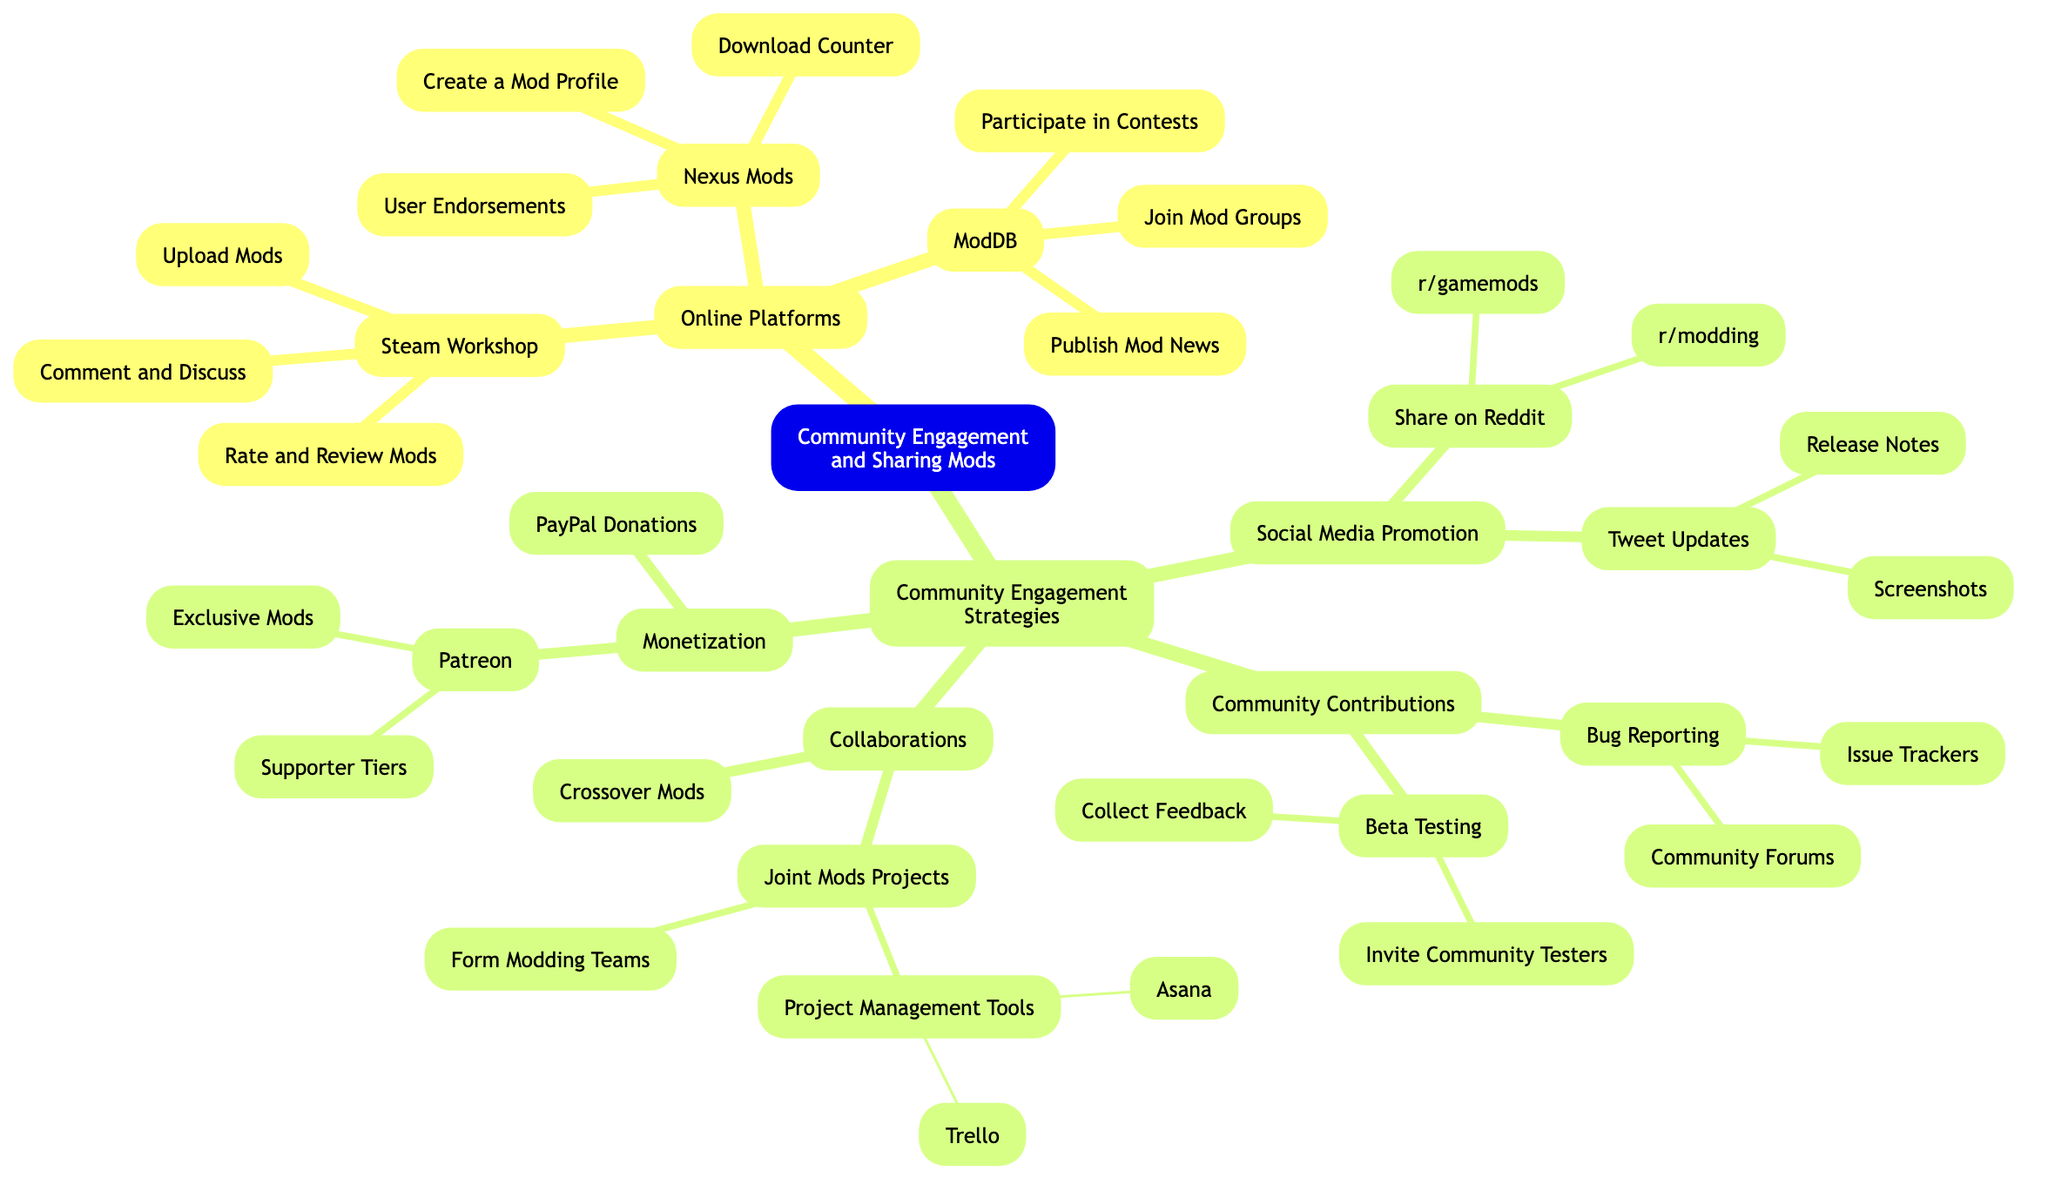What is the main root of the diagram? The main root of the diagram is labeled as "Community Engagement and Sharing Mods," which serves as the central theme connecting various elements beneath it.
Answer: Community Engagement and Sharing Mods How many online platforms are listed in the diagram? The diagram lists three online platforms: Steam Workshop, Nexus Mods, and ModDB. Therefore, the total count of online platforms is three.
Answer: 3 What can you do on Nexus Mods? The sub-elements under Nexus Mods include "Create a Mod Profile," "Download Counter," and "User Endorsements," which represent the actions available on this platform.
Answer: Create a Mod Profile, Download Counter, User Endorsements Which social media platform is mentioned for promotion besides Reddit? The diagram indicates "Tweet Updates" as a strategy for social media promotion in addition to sharing on Reddit.
Answer: Tweet Updates What activities fall under the community contributions section? Community Contributions includes two primary activities: "Beta Testing" and "Bug Reporting." The sub-elements under these categories further detail the actions within them.
Answer: Beta Testing, Bug Reporting Which project management tools are suggested for joint mods projects? The diagram specifies two project management tools under Joint Mods Projects: "Trello" and "Asana," indicating their use for managing collaborative modding efforts.
Answer: Trello, Asana How many types of monetization strategies are mentioned? There are two main strategies for monetization listed: "Patreon" and "PayPal Donations," indicating the ways mod creators might generate revenue.
Answer: 2 What is one form of community engagement activity related to feedback? The diagram highlights "Collect Feedback" as an important activity under Beta Testing, emphasizing its role in community collaboration and mod improvement.
Answer: Collect Feedback Which online platform allows for commenting and discussing mods? The online platform Steam Workshop provides features for users to "Comment and Discuss" mods, enhancing community interaction.
Answer: Steam Workshop 